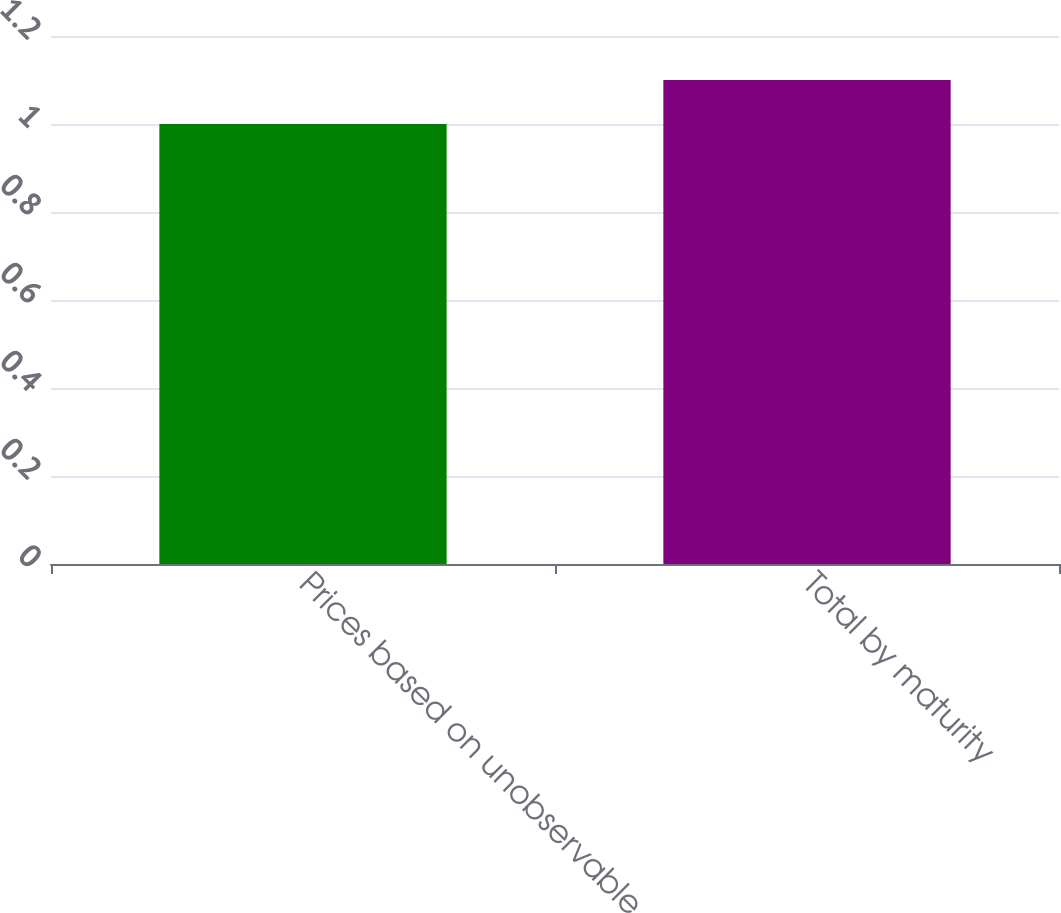Convert chart. <chart><loc_0><loc_0><loc_500><loc_500><bar_chart><fcel>Prices based on unobservable<fcel>Total by maturity<nl><fcel>1<fcel>1.1<nl></chart> 